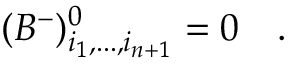Convert formula to latex. <formula><loc_0><loc_0><loc_500><loc_500>( B ^ { - } ) _ { i _ { 1 } , \dots , i _ { n + 1 } } ^ { 0 } = 0 .</formula> 